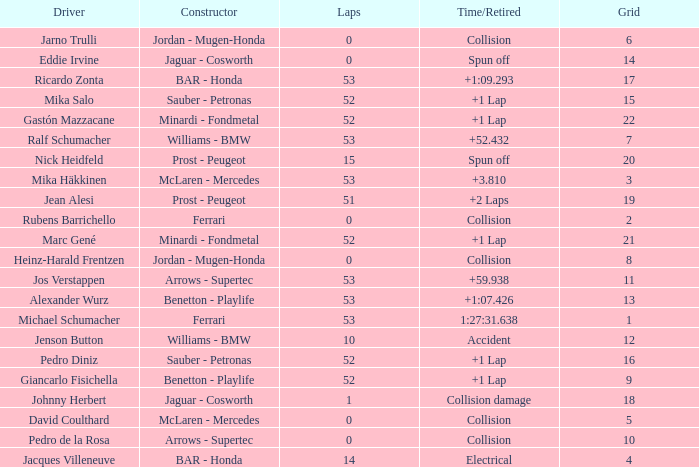How many laps did Ricardo Zonta have? 53.0. 